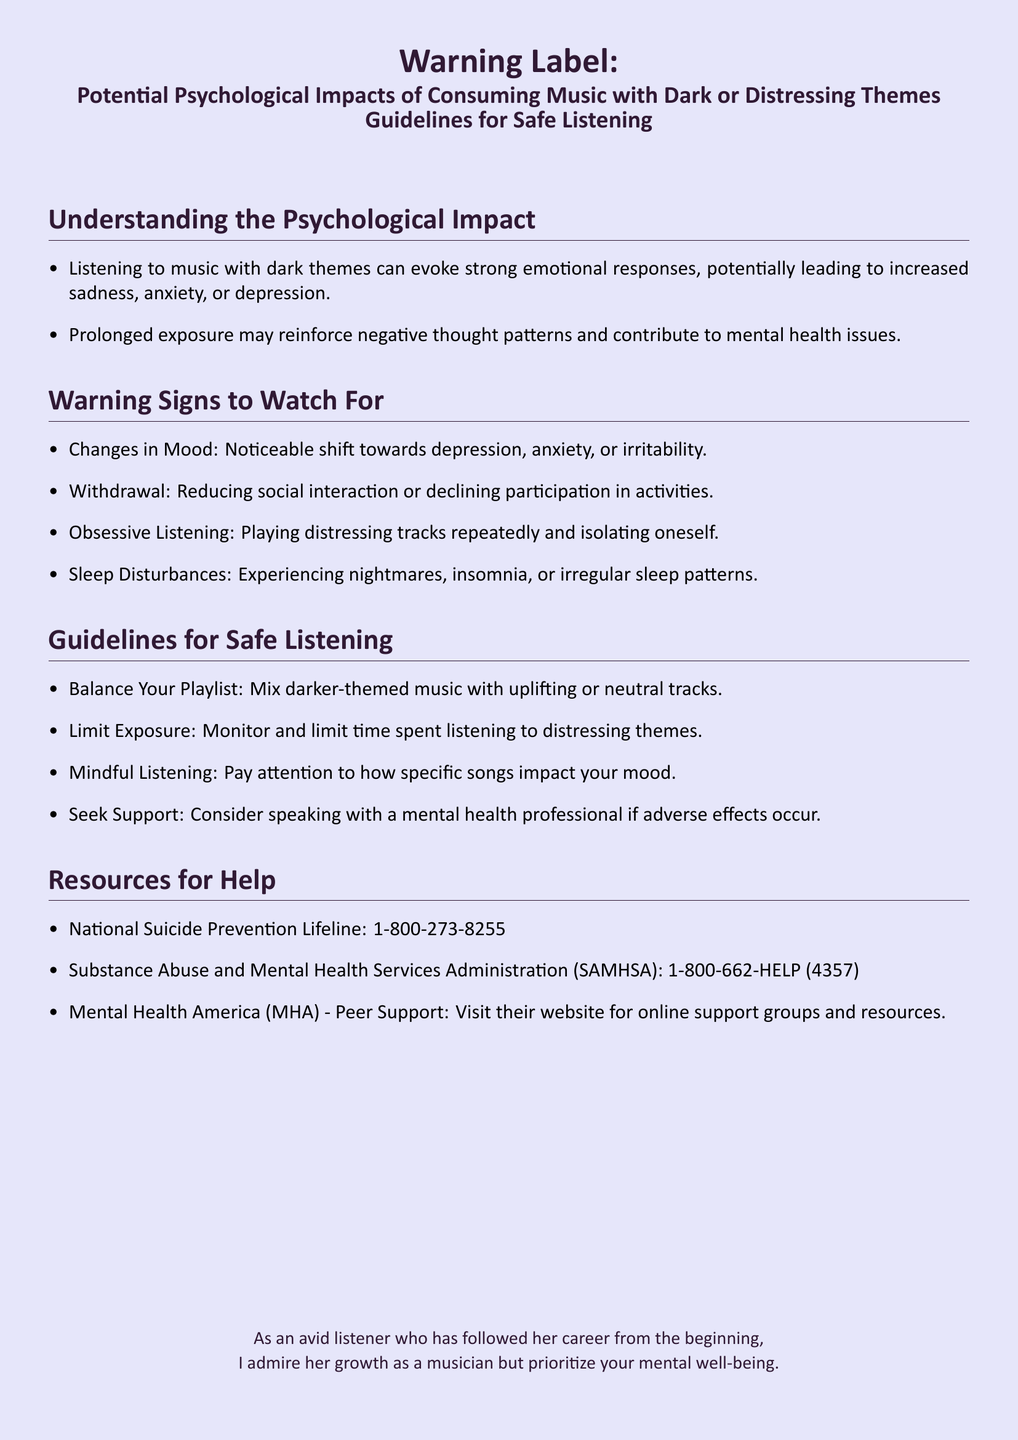What can consuming music with dark themes lead to? The document states that listening to such music can lead to increased sadness, anxiety, or depression.
Answer: Increased sadness, anxiety, or depression What are the warning signs related to music consumption? The document lists changes in mood, withdrawal, obsessive listening, and sleep disturbances as warning signs.
Answer: Changes in mood, withdrawal, obsessive listening, sleep disturbances What should you balance your playlist with? The document advises mixing darker-themed music with uplifting or neutral tracks.
Answer: Uplifting or neutral tracks What hotline is mentioned for suicide prevention? The document provides the National Suicide Prevention Lifeline number for support.
Answer: 1-800-273-8255 How can prolonged exposure to dark themes affect mental health? The document explains that it may reinforce negative thought patterns and contribute to mental health issues.
Answer: Reinforce negative thought patterns What type of music should be limited according to the guidelines? The guidelines recommend limiting exposure to distressing themes.
Answer: Distressing themes Name a resource mentioned for support. The document lists several resources, including the Substance Abuse and Mental Health Services Administration.
Answer: SAMHSA What should you do if you experience adverse effects from listening to such music? The document suggests considering speaking with a mental health professional.
Answer: Speak with a mental health professional What is the page color of the document? The document specifies that the page color is light purple.
Answer: Light purple 